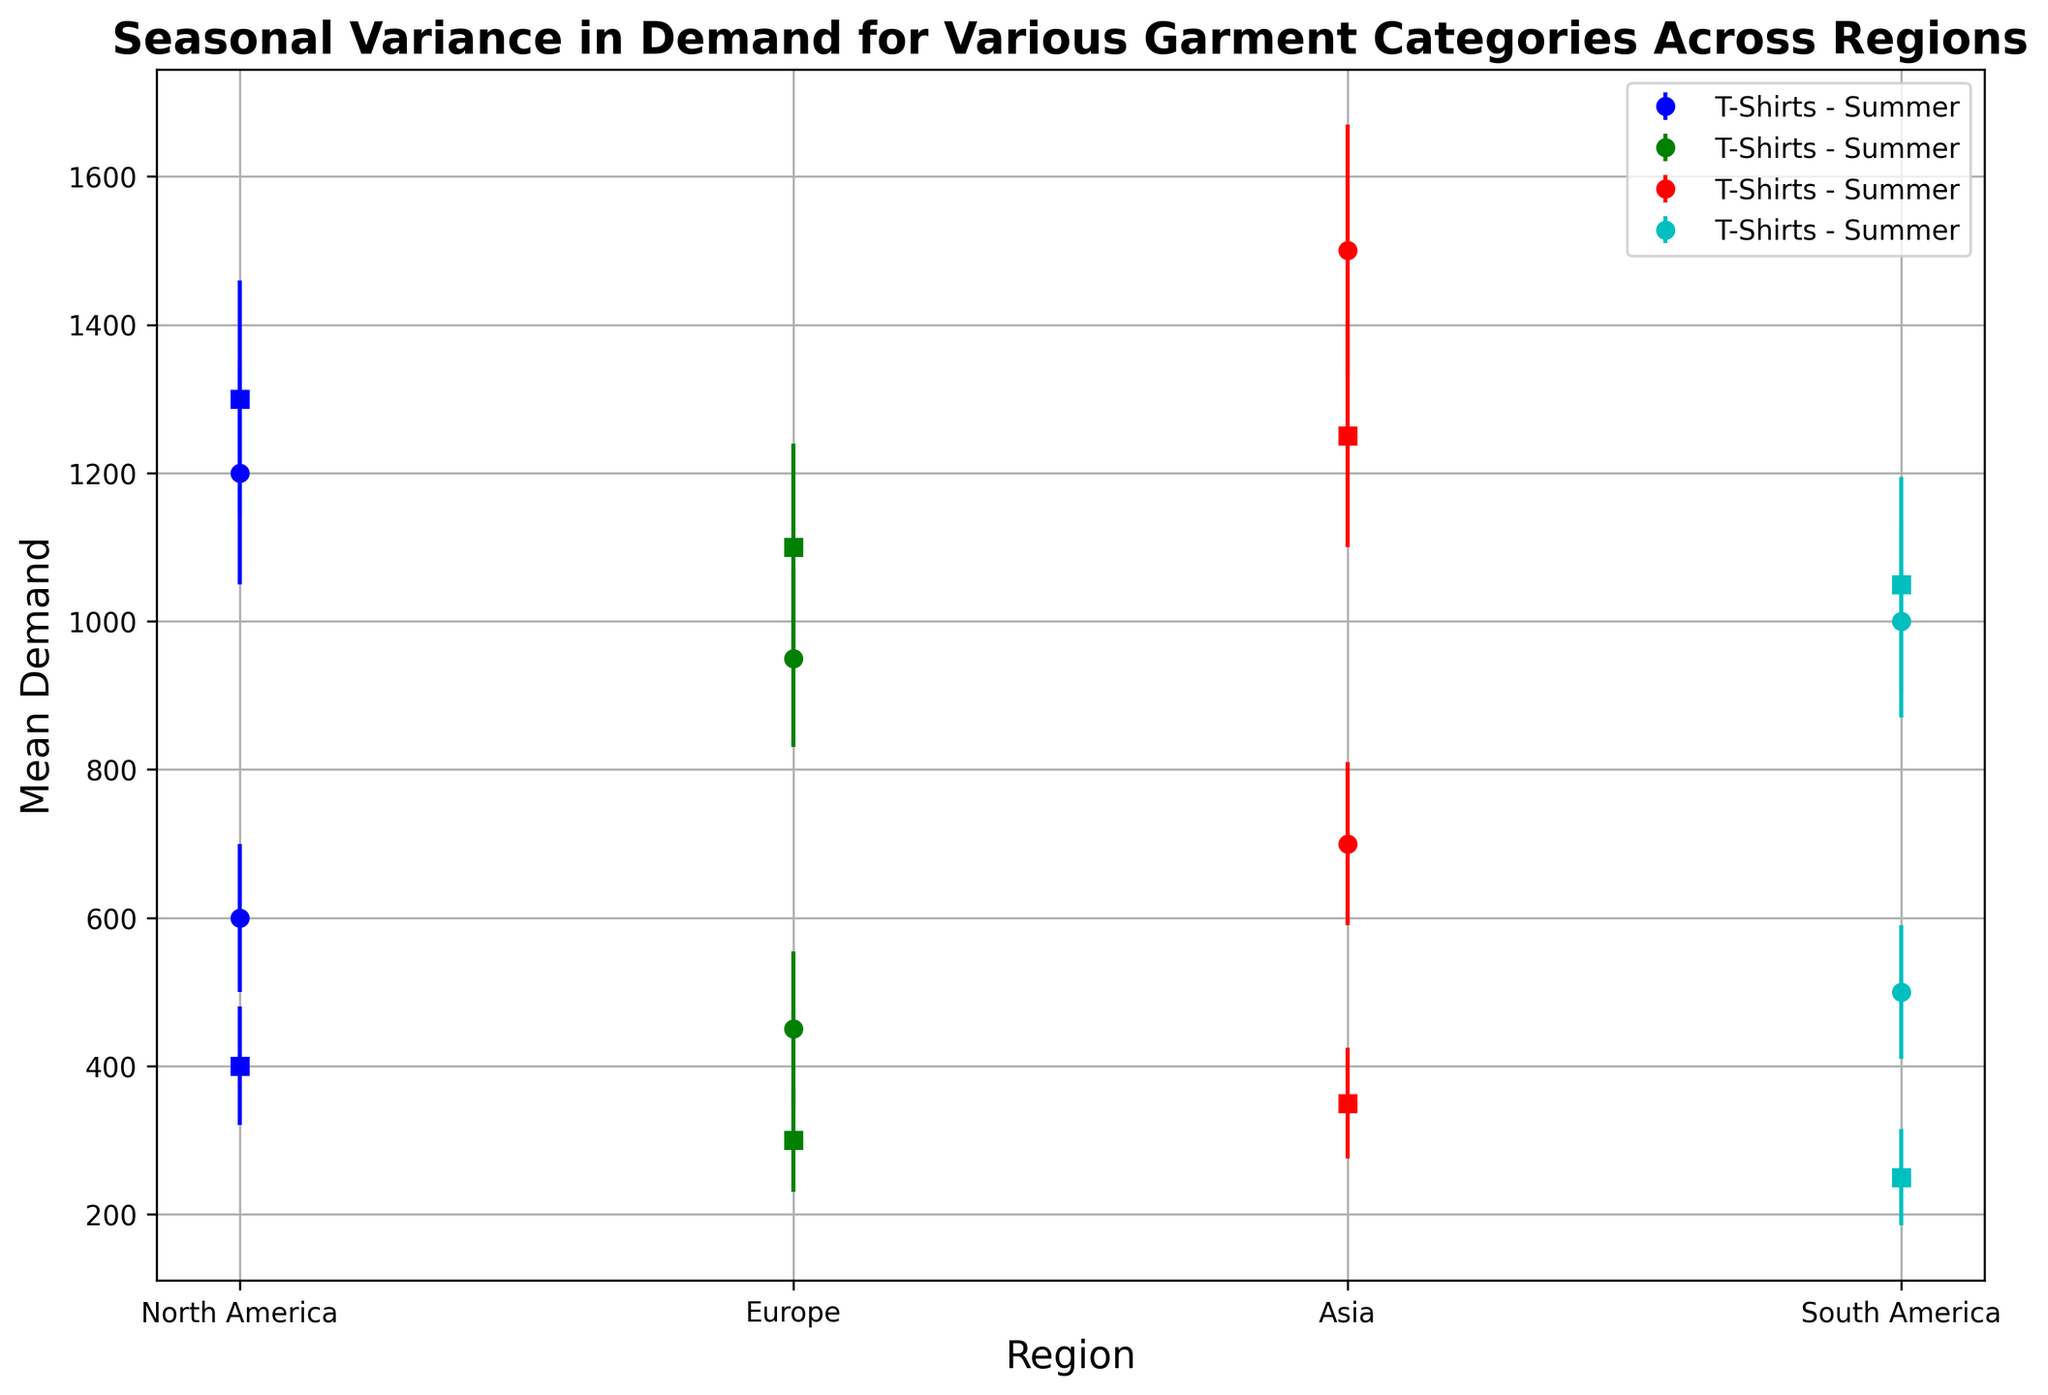What is the mean demand for T-Shirts in North America during the summer? To find the mean demand for T-Shirts in North America during the summer, locate the error bar that corresponds to North America, T-Shirts, and Summer on the plot. The mean demand is indicated by the vertical position of the marker on the plot.
Answer: 1200 Which region has the highest mean demand for Jackets in the winter? To determine the region with the highest mean demand for Jackets in the winter, compare the vertical positions of the markers for Jackets in the winter across all regions on the plot. The highest marker corresponds to the region with the highest mean demand.
Answer: North America What is the difference in mean demand for T-Shirts between summer and winter in Europe? To find the difference in mean demand for T-Shirts between summer and winter in Europe, locate the markers for Europe, T-Shirts in Summer and Winter on the plot. Subtract the mean demand for Winter from the mean demand for Summer.
Answer: 500 How does the demand variance for Jackets in winter in Europe compare to North America? Compare the lengths of the error bars for Jackets in winter between Europe and North America. The longer error bar indicates higher variance.
Answer: Lower in North America Which garment category has more seasonal variance in demand in Asia, T-Shirts or Jackets? Compare the sizes of the error bars for T-Shirts and Jackets in both summer and winter in Asia. Larger error bars indicate higher variance.
Answer: T-Shirts What is the sum of mean demands for Jackets in winter across all regions? To find the sum of mean demands for Jackets in winter across all regions, locate the markers for Jackets in winter in each region on the plot. Sum the mean demands for each region.
Answer: 4700 (1300 + 1100 + 1250 + 1050) Is the mean demand for T-Shirts in summer higher in Asia or North America? Compare the vertical positions of the markers for T-Shirts in summer between Asia and North America. The higher marker indicates the higher mean demand.
Answer: Asia What is the average mean demand for T-Shirts across all regions in winter? To find the average mean demand for T-Shirts across all regions in winter, locate the markers for T-Shirts in winter for each region. Sum the mean demands and divide by the number of regions.
Answer: 562.5 (600 + 450 + 700 + 500) / 4 How does the mean demand for T-Shirts in winter in South America compare to Europe? Compare the vertical positions of the markers for South America and Europe for T-Shirts in winter. The relative height of the markers indicates the comparison.
Answer: Higher in South America 